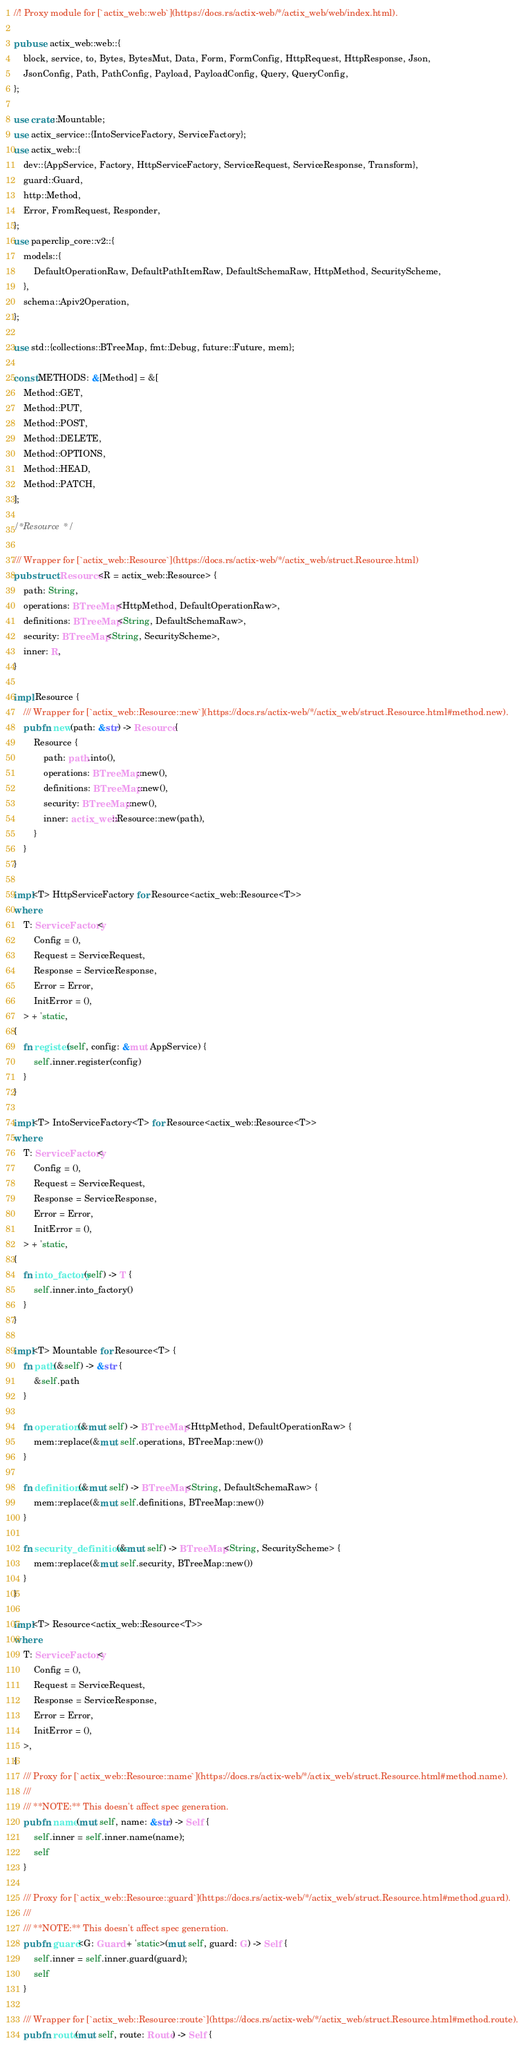<code> <loc_0><loc_0><loc_500><loc_500><_Rust_>//! Proxy module for [`actix_web::web`](https://docs.rs/actix-web/*/actix_web/web/index.html).

pub use actix_web::web::{
    block, service, to, Bytes, BytesMut, Data, Form, FormConfig, HttpRequest, HttpResponse, Json,
    JsonConfig, Path, PathConfig, Payload, PayloadConfig, Query, QueryConfig,
};

use crate::Mountable;
use actix_service::{IntoServiceFactory, ServiceFactory};
use actix_web::{
    dev::{AppService, Factory, HttpServiceFactory, ServiceRequest, ServiceResponse, Transform},
    guard::Guard,
    http::Method,
    Error, FromRequest, Responder,
};
use paperclip_core::v2::{
    models::{
        DefaultOperationRaw, DefaultPathItemRaw, DefaultSchemaRaw, HttpMethod, SecurityScheme,
    },
    schema::Apiv2Operation,
};

use std::{collections::BTreeMap, fmt::Debug, future::Future, mem};

const METHODS: &[Method] = &[
    Method::GET,
    Method::PUT,
    Method::POST,
    Method::DELETE,
    Method::OPTIONS,
    Method::HEAD,
    Method::PATCH,
];

/* Resource */

/// Wrapper for [`actix_web::Resource`](https://docs.rs/actix-web/*/actix_web/struct.Resource.html)
pub struct Resource<R = actix_web::Resource> {
    path: String,
    operations: BTreeMap<HttpMethod, DefaultOperationRaw>,
    definitions: BTreeMap<String, DefaultSchemaRaw>,
    security: BTreeMap<String, SecurityScheme>,
    inner: R,
}

impl Resource {
    /// Wrapper for [`actix_web::Resource::new`](https://docs.rs/actix-web/*/actix_web/struct.Resource.html#method.new).
    pub fn new(path: &str) -> Resource {
        Resource {
            path: path.into(),
            operations: BTreeMap::new(),
            definitions: BTreeMap::new(),
            security: BTreeMap::new(),
            inner: actix_web::Resource::new(path),
        }
    }
}

impl<T> HttpServiceFactory for Resource<actix_web::Resource<T>>
where
    T: ServiceFactory<
        Config = (),
        Request = ServiceRequest,
        Response = ServiceResponse,
        Error = Error,
        InitError = (),
    > + 'static,
{
    fn register(self, config: &mut AppService) {
        self.inner.register(config)
    }
}

impl<T> IntoServiceFactory<T> for Resource<actix_web::Resource<T>>
where
    T: ServiceFactory<
        Config = (),
        Request = ServiceRequest,
        Response = ServiceResponse,
        Error = Error,
        InitError = (),
    > + 'static,
{
    fn into_factory(self) -> T {
        self.inner.into_factory()
    }
}

impl<T> Mountable for Resource<T> {
    fn path(&self) -> &str {
        &self.path
    }

    fn operations(&mut self) -> BTreeMap<HttpMethod, DefaultOperationRaw> {
        mem::replace(&mut self.operations, BTreeMap::new())
    }

    fn definitions(&mut self) -> BTreeMap<String, DefaultSchemaRaw> {
        mem::replace(&mut self.definitions, BTreeMap::new())
    }

    fn security_definitions(&mut self) -> BTreeMap<String, SecurityScheme> {
        mem::replace(&mut self.security, BTreeMap::new())
    }
}

impl<T> Resource<actix_web::Resource<T>>
where
    T: ServiceFactory<
        Config = (),
        Request = ServiceRequest,
        Response = ServiceResponse,
        Error = Error,
        InitError = (),
    >,
{
    /// Proxy for [`actix_web::Resource::name`](https://docs.rs/actix-web/*/actix_web/struct.Resource.html#method.name).
    ///
    /// **NOTE:** This doesn't affect spec generation.
    pub fn name(mut self, name: &str) -> Self {
        self.inner = self.inner.name(name);
        self
    }

    /// Proxy for [`actix_web::Resource::guard`](https://docs.rs/actix-web/*/actix_web/struct.Resource.html#method.guard).
    ///
    /// **NOTE:** This doesn't affect spec generation.
    pub fn guard<G: Guard + 'static>(mut self, guard: G) -> Self {
        self.inner = self.inner.guard(guard);
        self
    }

    /// Wrapper for [`actix_web::Resource::route`](https://docs.rs/actix-web/*/actix_web/struct.Resource.html#method.route).
    pub fn route(mut self, route: Route) -> Self {</code> 